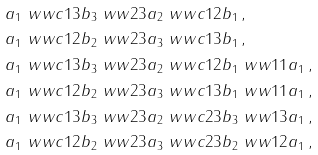Convert formula to latex. <formula><loc_0><loc_0><loc_500><loc_500>& a _ { 1 } \ w w c { 1 3 } b _ { 3 } \ w w { 2 3 } a _ { 2 } \ w w c { 1 2 } b _ { 1 } \, , \\ & a _ { 1 } \ w w c { 1 2 } b _ { 2 } \ w w { 2 3 } a _ { 3 } \ w w c { 1 3 } b _ { 1 } \, , \\ & a _ { 1 } \ w w c { 1 3 } b _ { 3 } \ w w { 2 3 } a _ { 2 } \ w w c { 1 2 } b _ { 1 } \ w w { 1 1 } a _ { 1 } \, , \\ & a _ { 1 } \ w w c { 1 2 } b _ { 2 } \ w w { 2 3 } a _ { 3 } \ w w c { 1 3 } b _ { 1 } \ w w { 1 1 } a _ { 1 } \, , \\ & a _ { 1 } \ w w c { 1 3 } b _ { 3 } \ w w { 2 3 } a _ { 2 } \ w w c { 2 3 } b _ { 3 } \ w w { 1 3 } a _ { 1 } \, , \\ & a _ { 1 } \ w w c { 1 2 } b _ { 2 } \ w w { 2 3 } a _ { 3 } \ w w c { 2 3 } b _ { 2 } \ w w { 1 2 } a _ { 1 } \, ,</formula> 